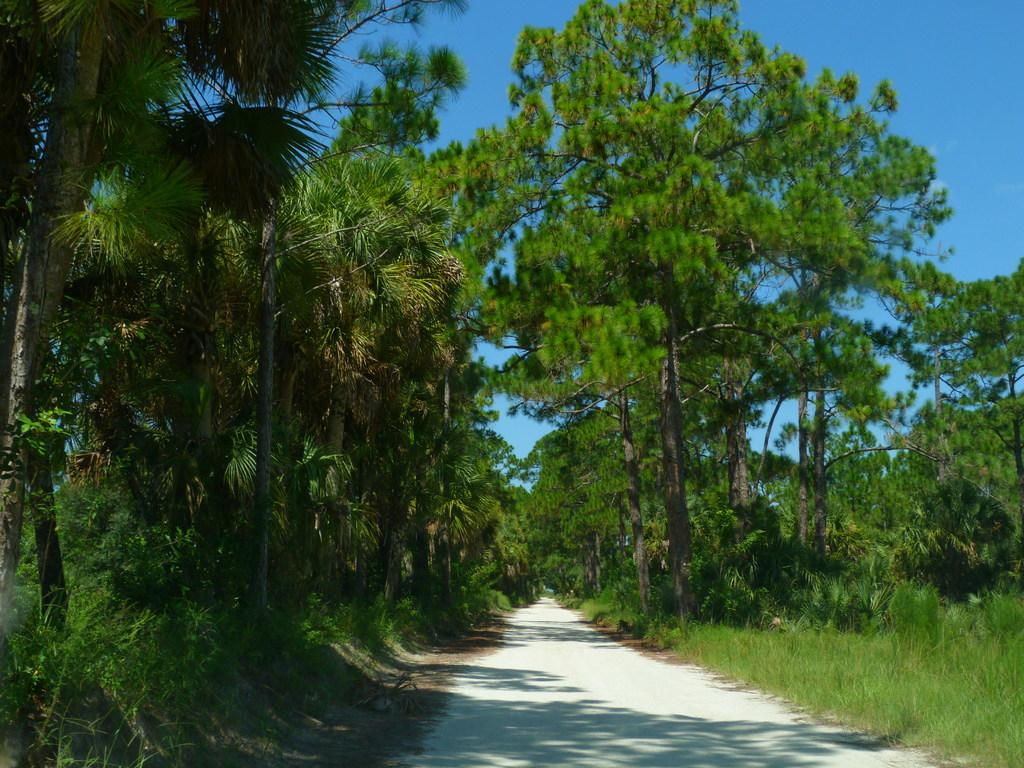What type of vegetation can be seen on both sides of the image? There are trees and plants on both the right and left sides of the image. What is visible at the top of the image? The sky is visible at the top of the image. How many ladybugs can be seen sleeping on the lizards in the image? There are no ladybugs or lizards present in the image. 